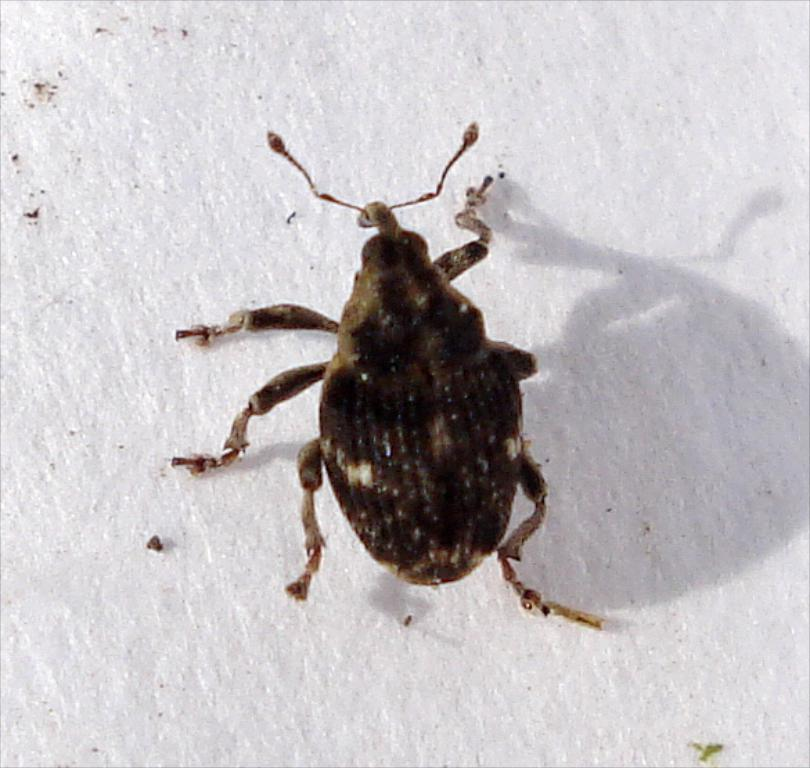What type of creature is in the image? There is an insect in the image. Where is the insect located? The insect is on the ground. What can be observed about the insect's shadow in the image? The shadow of the insect is visible on the ground. What items are on the list that the insect is holding in the image? There is no list or any items being held by the insect in the image. 